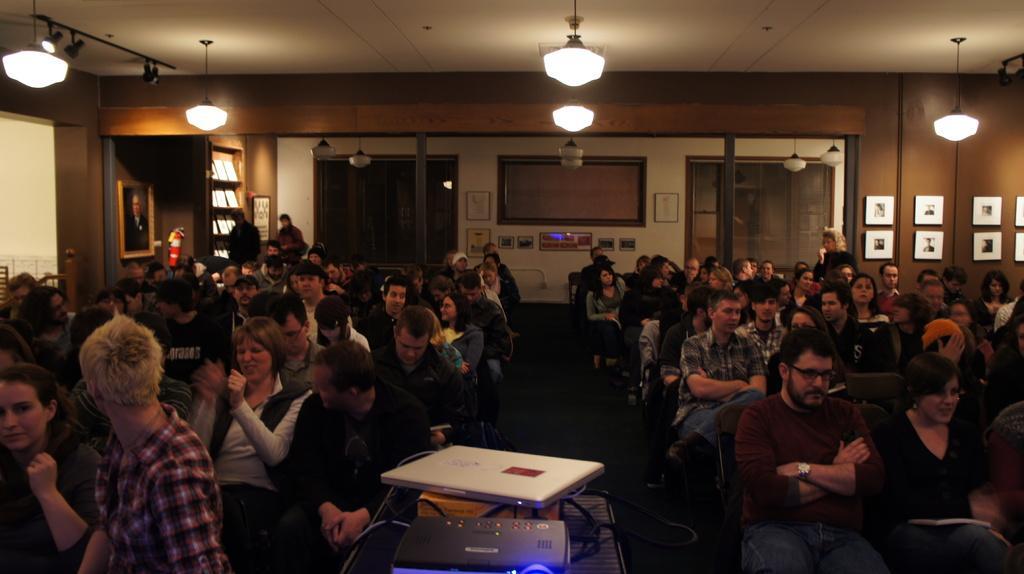Please provide a concise description of this image. In this picture, we see many people sitting on the chairs. At the bottom of the picture, we see a projector and a laptop are placed on the table. On the left side, we see a wall on which photo frame is placed. Beside that, there are windows. In the background, we see a white wall and a wall in brown color with many photo frames placed on it. This picture is clicked in a meeting hall. 